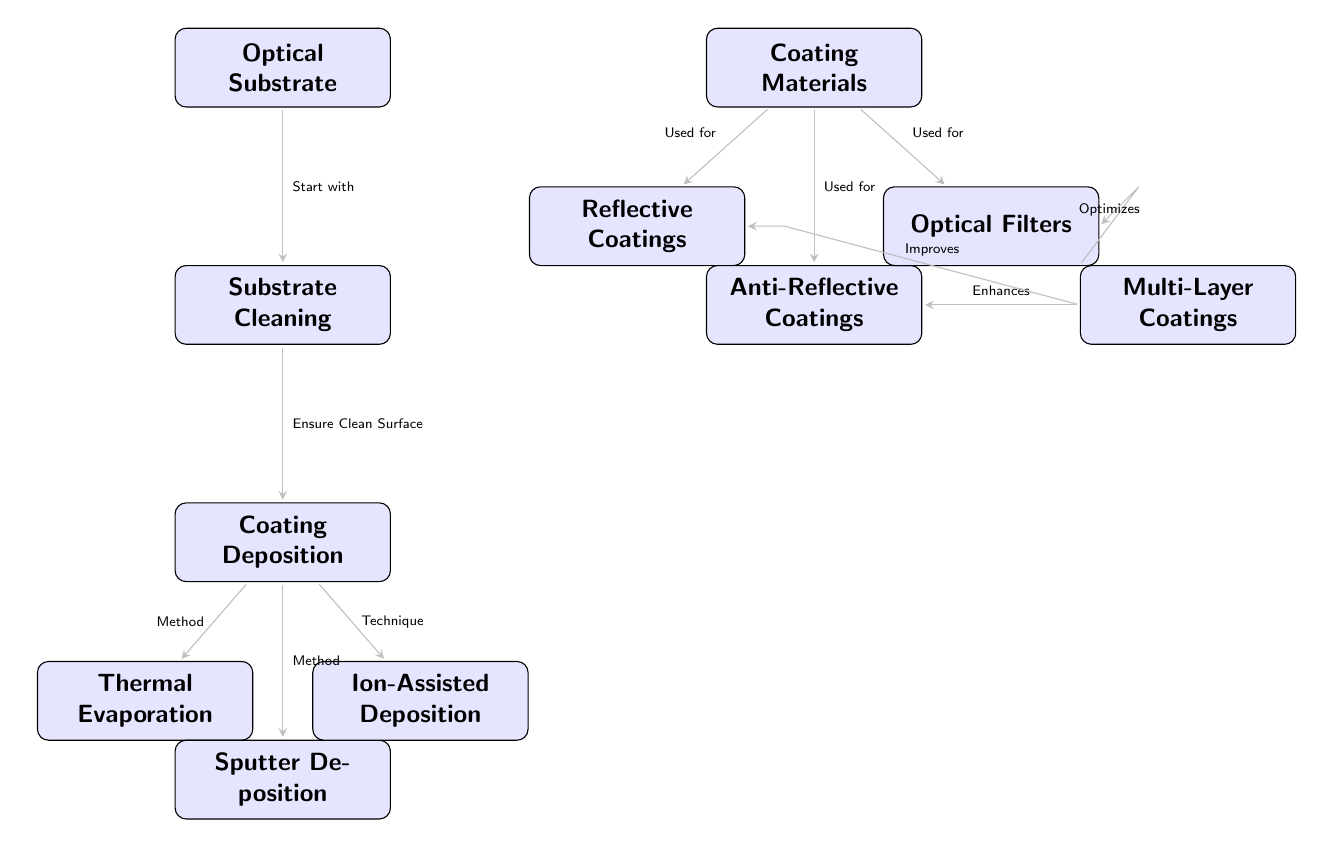What is the first step in the optical coating process? The diagram indicates that the first step after starting with the optical substrate is "Substrate Cleaning".
Answer: Substrate Cleaning How many coating deposition methods are listed in the diagram? The diagram displays three methods of coating deposition: Thermal Evaporation, Sputter Deposition, and Ion-Assisted Deposition.
Answer: 3 What type of coating is associated with "Optical Filters"? According to the diagram, Optical Filters are categorized under Coating Materials, which interacts with the nodes displaying their various uses.
Answer: Coating Materials What enhances the effectiveness of Anti-Reflective Coatings? The diagram shows that Multi-Layer Coatings enhance Anti-Reflective Coatings.
Answer: Multi-Layer Coatings Which deposition method is shown on the left side of the coating deposition node? The diagram specifies that Thermal Evaporation is placed on the left side of the Coating Deposition node.
Answer: Thermal Evaporation What type of coatings does the optical coating process produce? The diagram categorizes the types of coatings produced, naming them Reflective Coatings, Anti-Reflective Coatings, and Optical Filters.
Answer: Reflective Coatings, Anti-Reflective Coatings, Optical Filters Which node indicates that the surface should be clean before proceeding to deposition? The step immediately following the Optical Substrate node is the Cleaning step, which emphasizes the necessity for a clean surface prior to deposition.
Answer: Substrate Cleaning What relationship is established between Multi-Layer Coatings and Reflective Coatings? The diagram indicates that Multi-Layer Coatings improve Reflective Coatings, showing a directional relationship between these two nodes.
Answer: Improves How are the Coating Materials utilized in the process? The diagram shows that Coating Materials are connected to three types of coatings, specifically indicating their application in Reflective Coatings, Anti-Reflective Coatings, and Optical Filters.
Answer: Used for 